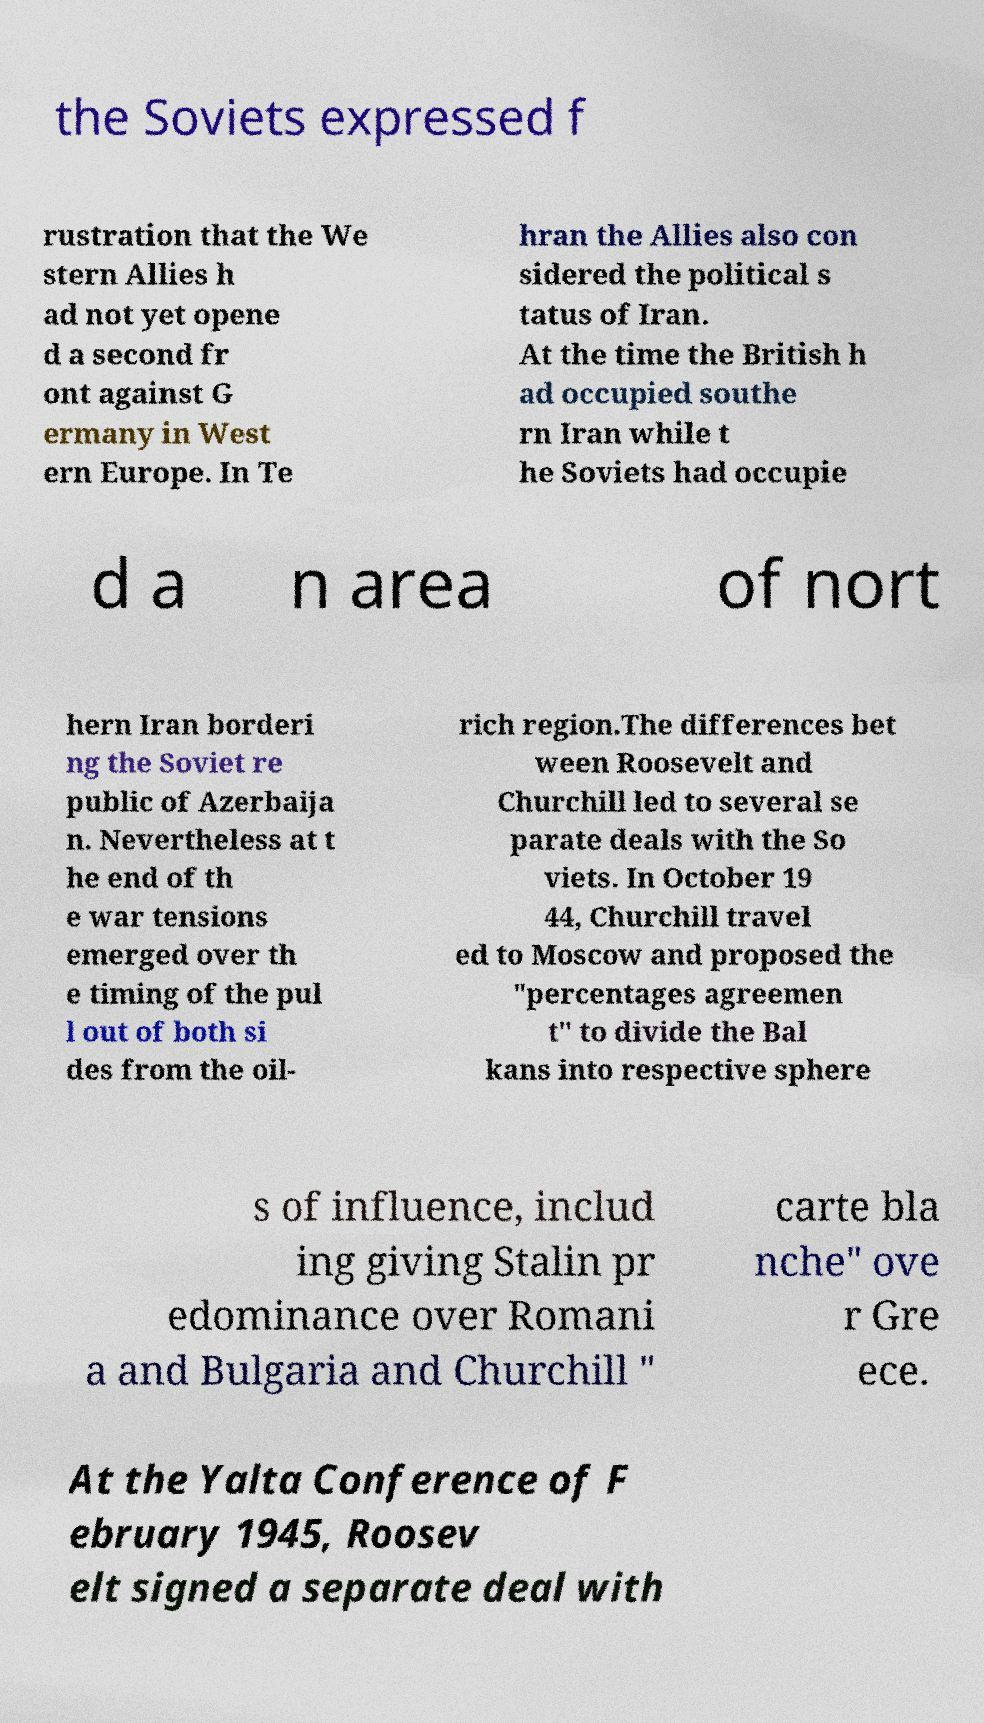For documentation purposes, I need the text within this image transcribed. Could you provide that? the Soviets expressed f rustration that the We stern Allies h ad not yet opene d a second fr ont against G ermany in West ern Europe. In Te hran the Allies also con sidered the political s tatus of Iran. At the time the British h ad occupied southe rn Iran while t he Soviets had occupie d a n area of nort hern Iran borderi ng the Soviet re public of Azerbaija n. Nevertheless at t he end of th e war tensions emerged over th e timing of the pul l out of both si des from the oil- rich region.The differences bet ween Roosevelt and Churchill led to several se parate deals with the So viets. In October 19 44, Churchill travel ed to Moscow and proposed the "percentages agreemen t" to divide the Bal kans into respective sphere s of influence, includ ing giving Stalin pr edominance over Romani a and Bulgaria and Churchill " carte bla nche" ove r Gre ece. At the Yalta Conference of F ebruary 1945, Roosev elt signed a separate deal with 